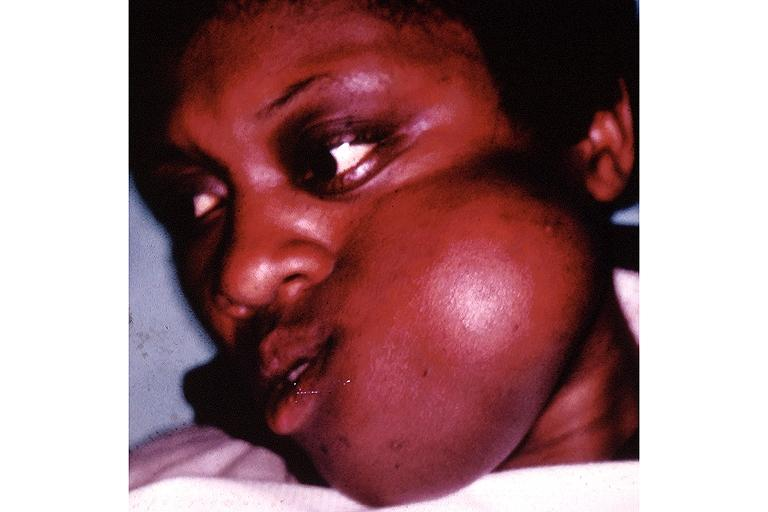does this image show fibrous dysplasia?
Answer the question using a single word or phrase. Yes 